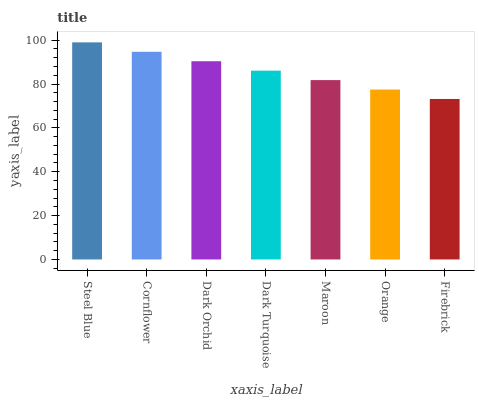Is Firebrick the minimum?
Answer yes or no. Yes. Is Steel Blue the maximum?
Answer yes or no. Yes. Is Cornflower the minimum?
Answer yes or no. No. Is Cornflower the maximum?
Answer yes or no. No. Is Steel Blue greater than Cornflower?
Answer yes or no. Yes. Is Cornflower less than Steel Blue?
Answer yes or no. Yes. Is Cornflower greater than Steel Blue?
Answer yes or no. No. Is Steel Blue less than Cornflower?
Answer yes or no. No. Is Dark Turquoise the high median?
Answer yes or no. Yes. Is Dark Turquoise the low median?
Answer yes or no. Yes. Is Maroon the high median?
Answer yes or no. No. Is Steel Blue the low median?
Answer yes or no. No. 